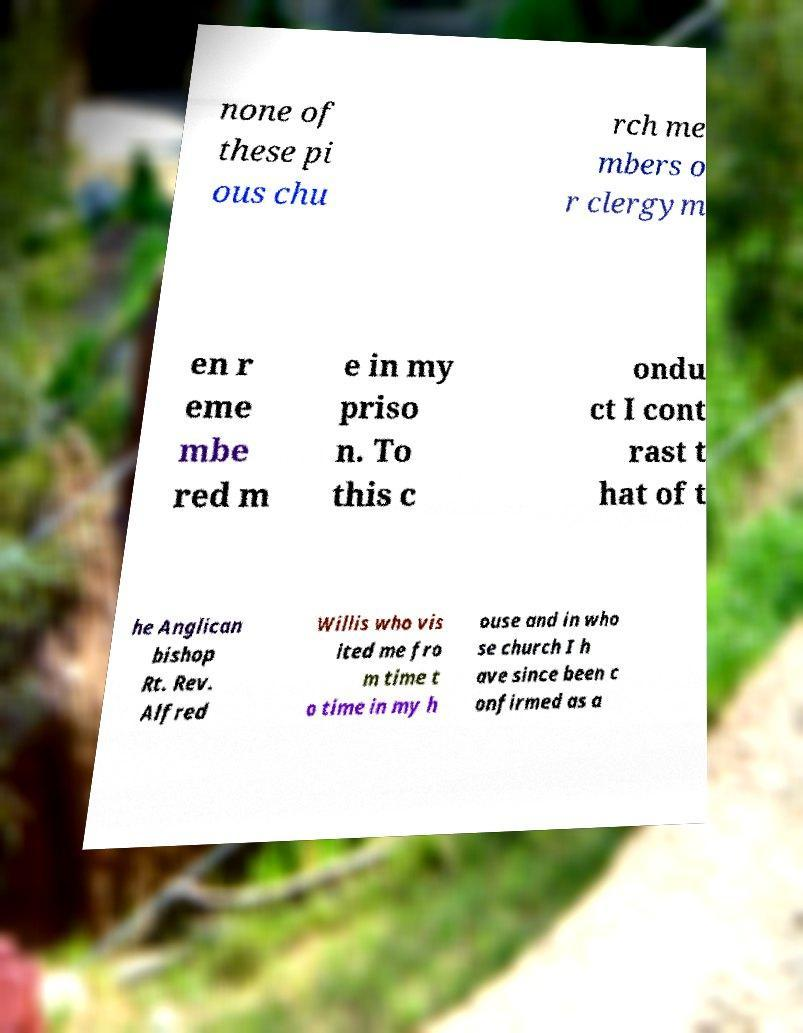Could you extract and type out the text from this image? none of these pi ous chu rch me mbers o r clergym en r eme mbe red m e in my priso n. To this c ondu ct I cont rast t hat of t he Anglican bishop Rt. Rev. Alfred Willis who vis ited me fro m time t o time in my h ouse and in who se church I h ave since been c onfirmed as a 